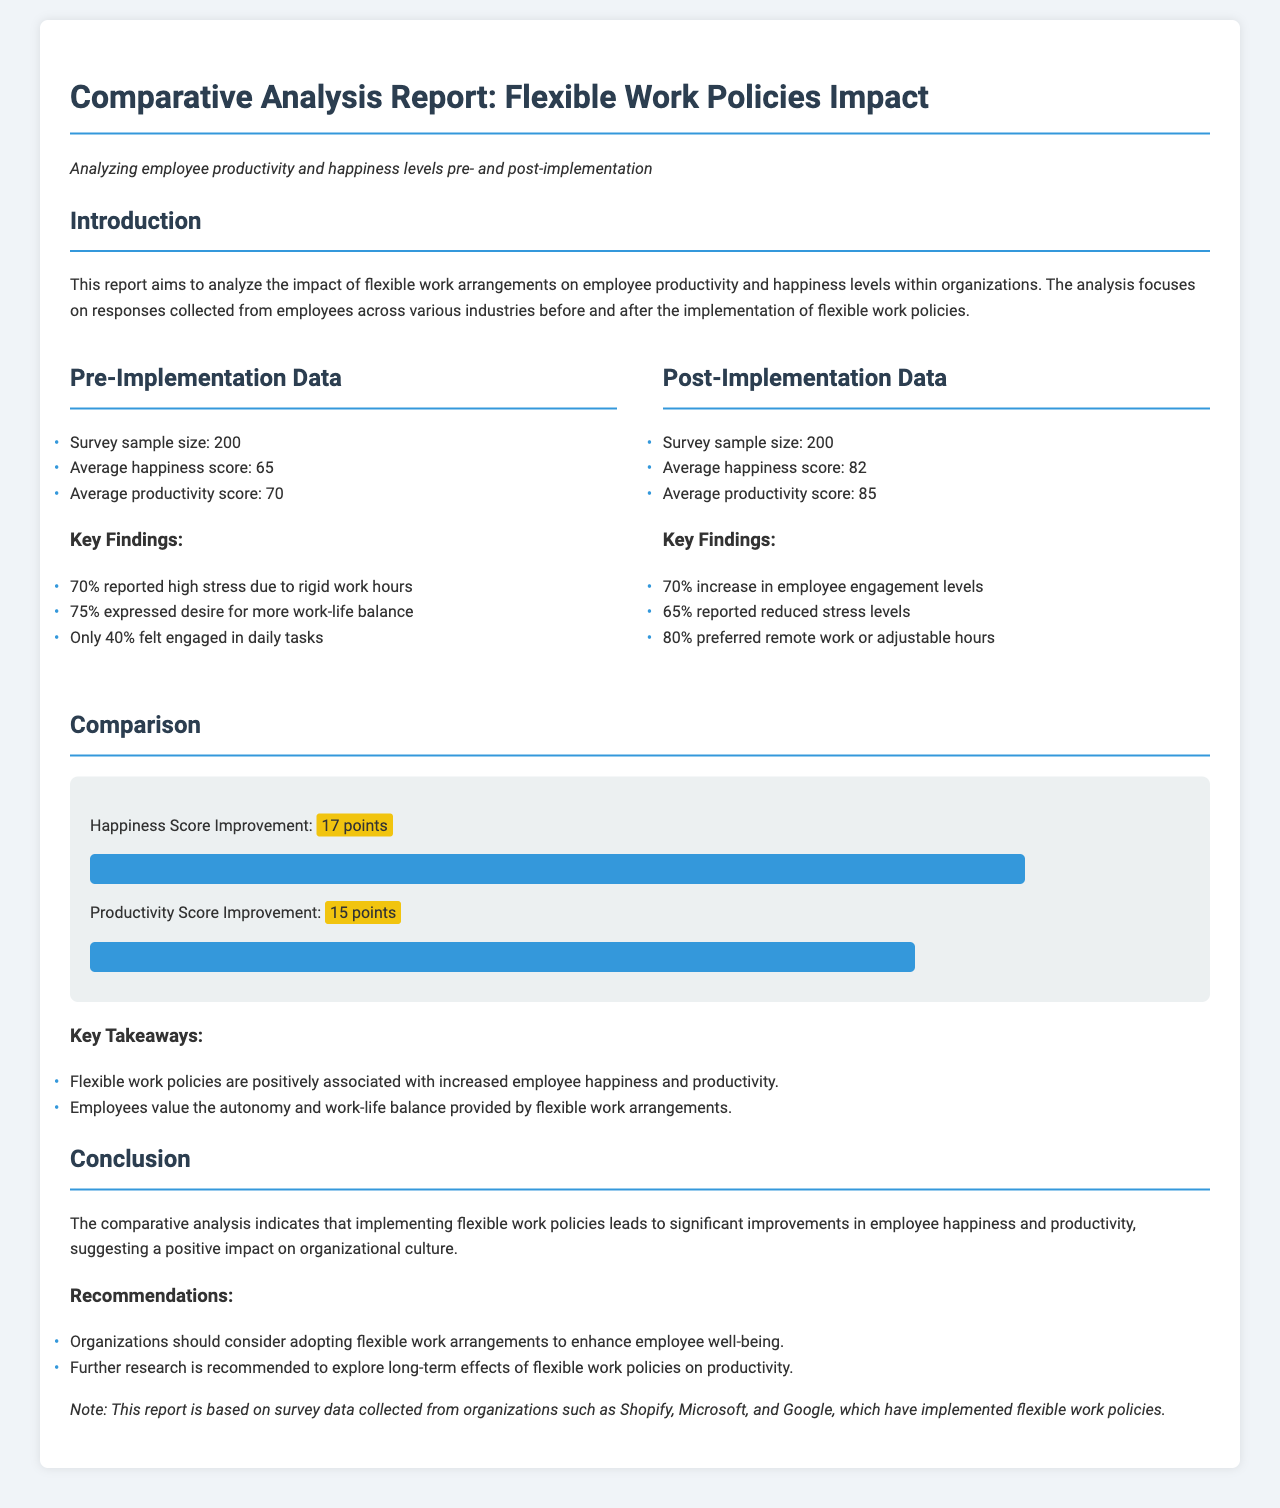What was the average happiness score pre-implementation? The average happiness score pre-implementation is stated in the document as 65.
Answer: 65 What was the average productivity score post-implementation? The average productivity score post-implementation is provided as 85.
Answer: 85 What percentage of employees reported high stress due to rigid work hours before the implementation? The document mentions that 70% reported high stress due to rigid work hours pre-implementation.
Answer: 70% How many points did the happiness score improve after implementing flexible work policies? The document indicates that the happiness score improved by 17 points after implementation.
Answer: 17 points What do 80% of employees prefer regarding work arrangements post-implementation? According to the report, 80% preferred remote work or adjustable hours after the implementation.
Answer: remote work or adjustable hours What is one key takeaway mentioned in the report? A key takeaway states that flexible work policies are positively associated with increased employee happiness and productivity.
Answer: Increased employee happiness and productivity What was the sample size for both pre-and post-implementation surveys? The survey sample size for both pre-and post-implementation is indicated as 200.
Answer: 200 What percentage of employees expressed a desire for more work-life balance pre-implementation? The document states that 75% expressed a desire for more work-life balance before the implementation.
Answer: 75% What is recommended for organizations based on the report's findings? One recommendation is that organizations should consider adopting flexible work arrangements to enhance employee well-being.
Answer: Adopt flexible work arrangements 